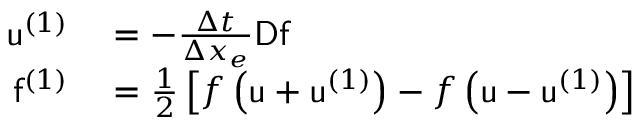<formula> <loc_0><loc_0><loc_500><loc_500>\begin{array} { r l } { u ^ { ( 1 ) } } & = - \frac { \Delta t } { \Delta x _ { e } } D f } \\ { f ^ { ( 1 ) } } & = \frac { 1 } { 2 } \left [ f \left ( u + u ^ { ( 1 ) } \right ) - f \left ( u - u ^ { ( 1 ) } \right ) \right ] } \end{array}</formula> 